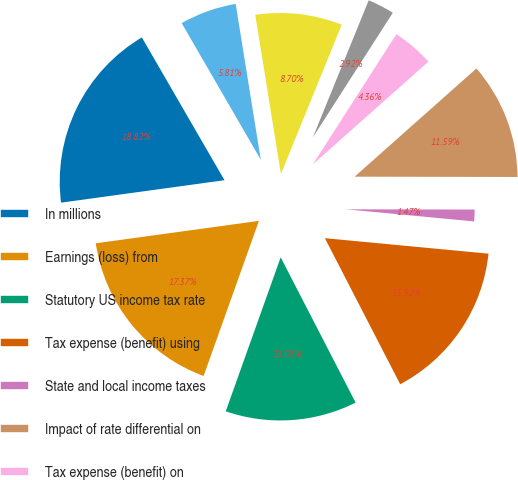<chart> <loc_0><loc_0><loc_500><loc_500><pie_chart><fcel>In millions<fcel>Earnings (loss) from<fcel>Statutory US income tax rate<fcel>Tax expense (benefit) using<fcel>State and local income taxes<fcel>Impact of rate differential on<fcel>Tax expense (benefit) on<fcel>Non-deductible business<fcel>US tax on non-US earnings<fcel>Foreign tax credits<nl><fcel>18.82%<fcel>17.37%<fcel>13.03%<fcel>15.92%<fcel>1.47%<fcel>11.59%<fcel>4.36%<fcel>2.92%<fcel>8.7%<fcel>5.81%<nl></chart> 